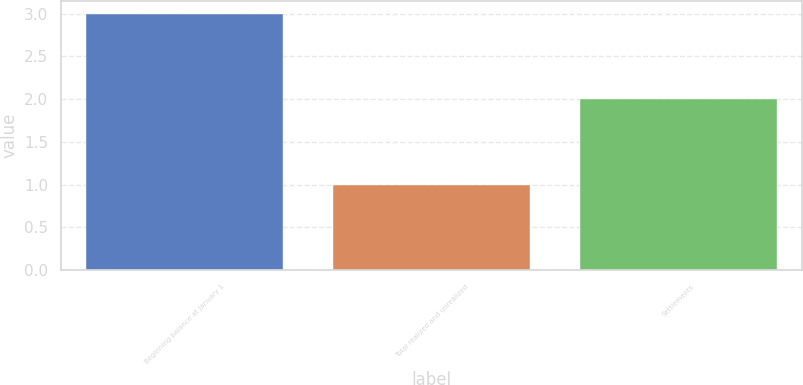Convert chart to OTSL. <chart><loc_0><loc_0><loc_500><loc_500><bar_chart><fcel>Beginning balance at January 1<fcel>Total realized and unrealized<fcel>Settlements<nl><fcel>3<fcel>1<fcel>2<nl></chart> 